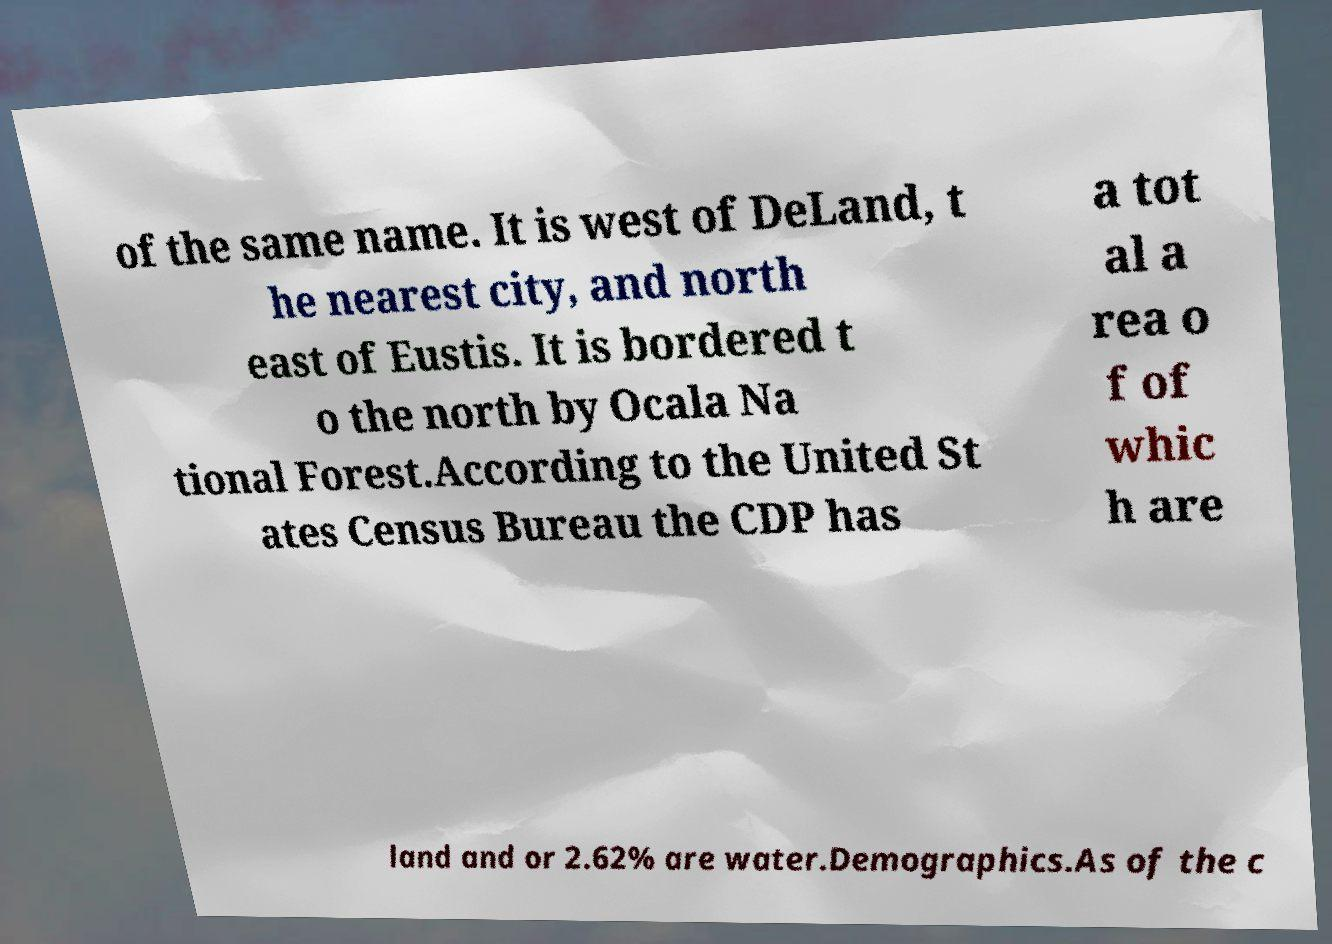Could you extract and type out the text from this image? of the same name. It is west of DeLand, t he nearest city, and north east of Eustis. It is bordered t o the north by Ocala Na tional Forest.According to the United St ates Census Bureau the CDP has a tot al a rea o f of whic h are land and or 2.62% are water.Demographics.As of the c 